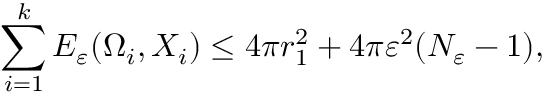<formula> <loc_0><loc_0><loc_500><loc_500>\sum _ { i = 1 } ^ { k } E _ { \varepsilon } ( \Omega _ { i } , X _ { i } ) \leq 4 \pi r _ { 1 } ^ { 2 } + 4 \pi \varepsilon ^ { 2 } ( N _ { \varepsilon } - 1 ) ,</formula> 